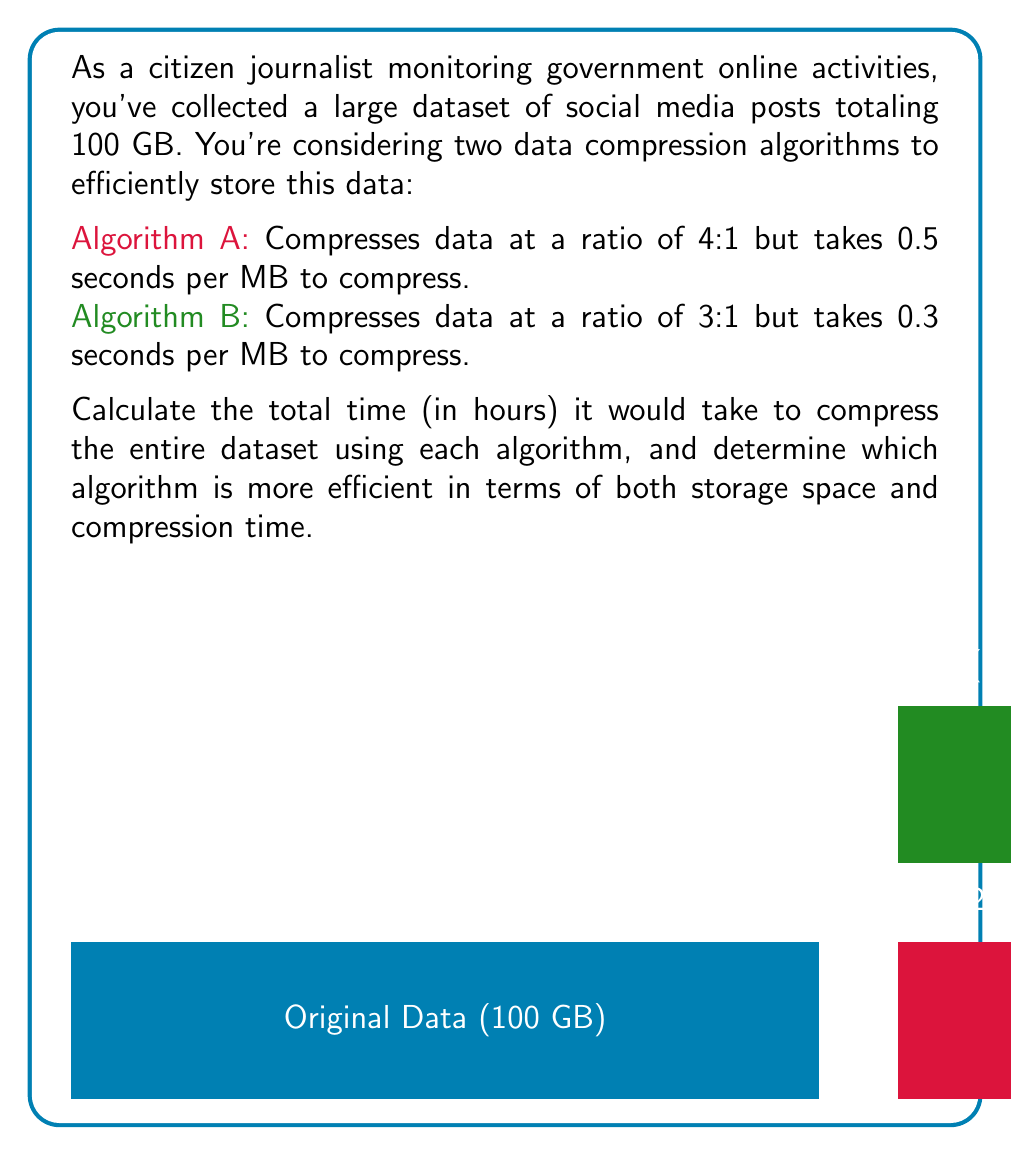Help me with this question. Let's approach this step-by-step:

1) First, let's convert GB to MB:
   100 GB = 100 * 1024 MB = 102,400 MB

2) For Algorithm A:
   - Compression ratio is 4:1, so compressed size = 102,400 / 4 = 25,600 MB
   - Time to compress 1 MB = 0.5 seconds
   - Total time = 102,400 * 0.5 = 51,200 seconds

3) For Algorithm B:
   - Compression ratio is 3:1, so compressed size = 102,400 / 3 ≈ 34,133.33 MB
   - Time to compress 1 MB = 0.3 seconds
   - Total time = 102,400 * 0.3 = 30,720 seconds

4) Convert seconds to hours:
   - Algorithm A: 51,200 / 3600 ≈ 14.22 hours
   - Algorithm B: 30,720 / 3600 = 8.53 hours

5) Efficiency comparison:
   - Storage space: 
     Algorithm A is better (25,600 MB < 34,133.33 MB)
   - Compression time: 
     Algorithm B is better (8.53 hours < 14.22 hours)

6) Overall efficiency:
   Algorithm B is more efficient in terms of compression time, while Algorithm A is more efficient in terms of storage space. The choice depends on whether storage space or processing time is more critical for the citizen journalist's needs.

The time difference is:
$$14.22 - 8.53 = 5.69$$ hours

The storage difference is:
$$34,133.33 - 25,600 = 8,533.33$$ MB or about 8.33 GB
Answer: Algorithm A: 14.22 hours, 25 GB
Algorithm B: 8.53 hours, 33.33 GB
B is faster, A saves more space 